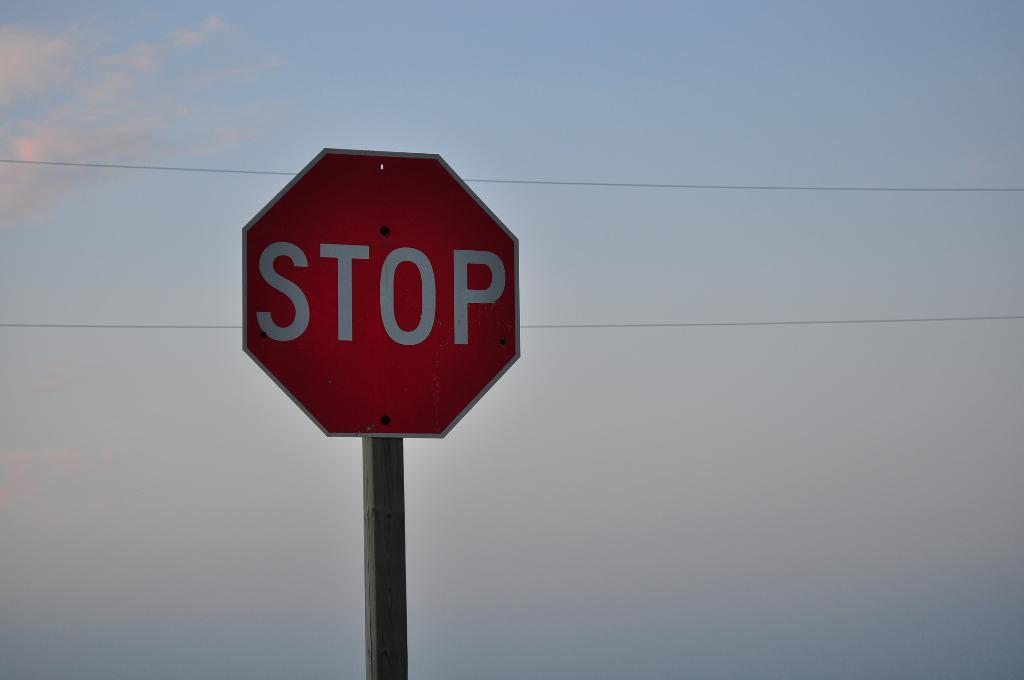<image>
Present a compact description of the photo's key features. A STOP sign at sunset in front of a blue sky. 